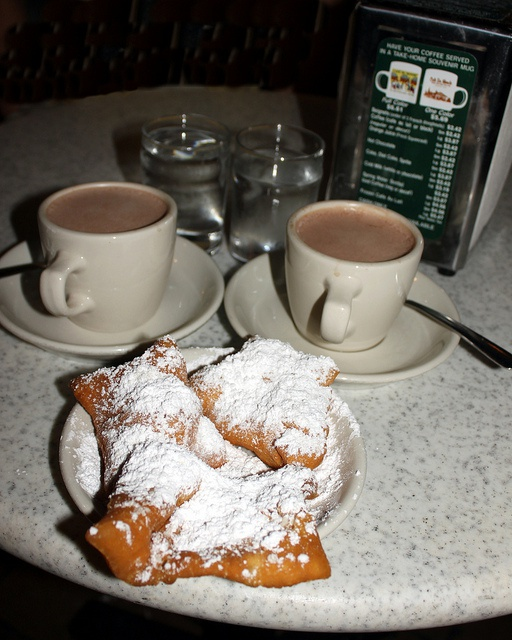Describe the objects in this image and their specific colors. I can see dining table in black, darkgray, lightgray, and gray tones, cup in black, darkgray, maroon, and gray tones, cup in black, darkgray, gray, and lightgray tones, cup in black and gray tones, and cup in black and gray tones in this image. 